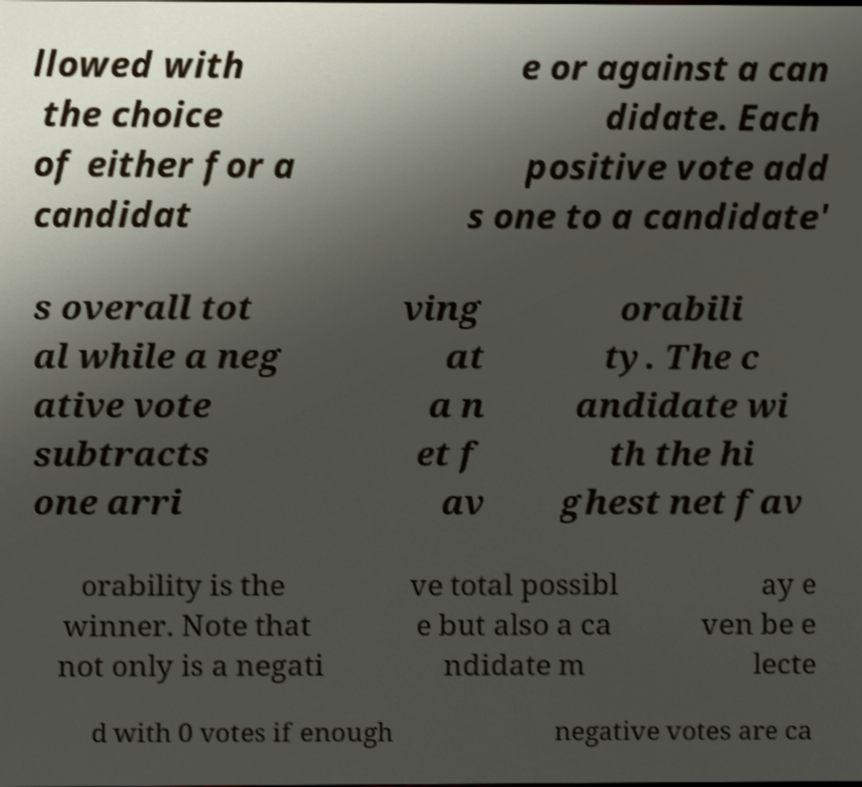Please identify and transcribe the text found in this image. llowed with the choice of either for a candidat e or against a can didate. Each positive vote add s one to a candidate' s overall tot al while a neg ative vote subtracts one arri ving at a n et f av orabili ty. The c andidate wi th the hi ghest net fav orability is the winner. Note that not only is a negati ve total possibl e but also a ca ndidate m ay e ven be e lecte d with 0 votes if enough negative votes are ca 